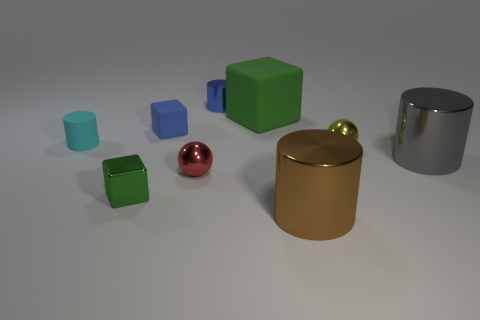Add 1 large metallic cylinders. How many objects exist? 10 Subtract all cylinders. How many objects are left? 5 Add 5 small metal cylinders. How many small metal cylinders exist? 6 Subtract 1 blue blocks. How many objects are left? 8 Subtract all blue cubes. Subtract all small cyan rubber objects. How many objects are left? 7 Add 9 red metal balls. How many red metal balls are left? 10 